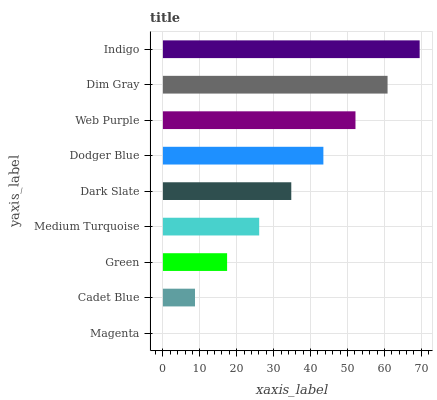Is Magenta the minimum?
Answer yes or no. Yes. Is Indigo the maximum?
Answer yes or no. Yes. Is Cadet Blue the minimum?
Answer yes or no. No. Is Cadet Blue the maximum?
Answer yes or no. No. Is Cadet Blue greater than Magenta?
Answer yes or no. Yes. Is Magenta less than Cadet Blue?
Answer yes or no. Yes. Is Magenta greater than Cadet Blue?
Answer yes or no. No. Is Cadet Blue less than Magenta?
Answer yes or no. No. Is Dark Slate the high median?
Answer yes or no. Yes. Is Dark Slate the low median?
Answer yes or no. Yes. Is Cadet Blue the high median?
Answer yes or no. No. Is Indigo the low median?
Answer yes or no. No. 